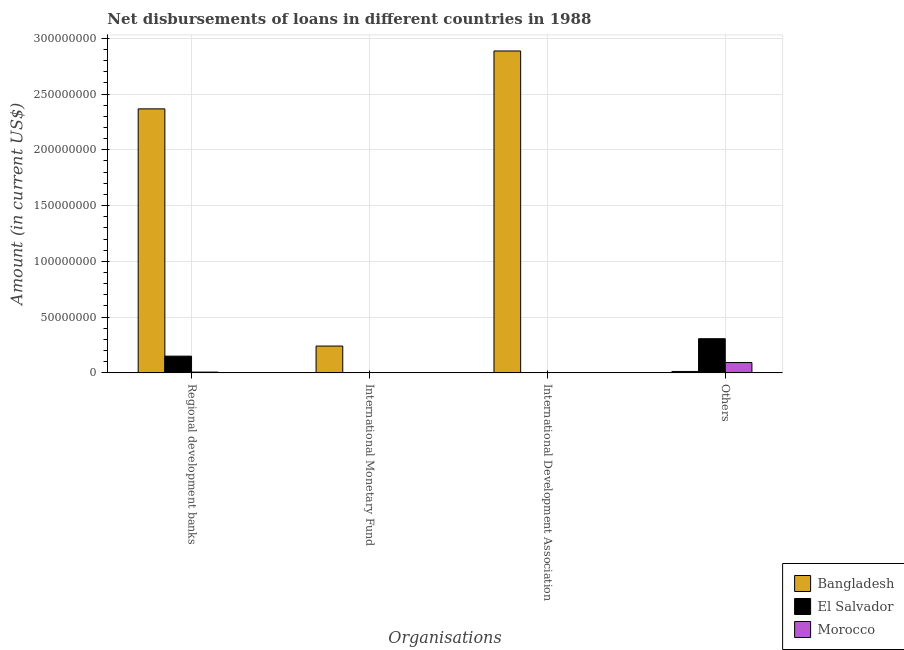What is the label of the 1st group of bars from the left?
Give a very brief answer. Regional development banks. What is the amount of loan disimbursed by other organisations in Morocco?
Your answer should be very brief. 9.26e+06. Across all countries, what is the maximum amount of loan disimbursed by international development association?
Offer a very short reply. 2.89e+08. In which country was the amount of loan disimbursed by regional development banks maximum?
Your response must be concise. Bangladesh. What is the total amount of loan disimbursed by other organisations in the graph?
Your response must be concise. 4.11e+07. What is the difference between the amount of loan disimbursed by other organisations in Morocco and that in El Salvador?
Provide a succinct answer. -2.14e+07. What is the difference between the amount of loan disimbursed by other organisations in Morocco and the amount of loan disimbursed by international monetary fund in Bangladesh?
Keep it short and to the point. -1.48e+07. What is the average amount of loan disimbursed by other organisations per country?
Your answer should be compact. 1.37e+07. What is the difference between the amount of loan disimbursed by other organisations and amount of loan disimbursed by international development association in Bangladesh?
Ensure brevity in your answer.  -2.87e+08. In how many countries, is the amount of loan disimbursed by regional development banks greater than 150000000 US$?
Offer a very short reply. 1. What is the ratio of the amount of loan disimbursed by regional development banks in El Salvador to that in Morocco?
Offer a very short reply. 21.62. Is the amount of loan disimbursed by other organisations in El Salvador less than that in Morocco?
Your response must be concise. No. Is the difference between the amount of loan disimbursed by regional development banks in Morocco and Bangladesh greater than the difference between the amount of loan disimbursed by other organisations in Morocco and Bangladesh?
Give a very brief answer. No. What is the difference between the highest and the second highest amount of loan disimbursed by other organisations?
Provide a short and direct response. 2.14e+07. What is the difference between the highest and the lowest amount of loan disimbursed by international monetary fund?
Provide a short and direct response. 2.40e+07. In how many countries, is the amount of loan disimbursed by regional development banks greater than the average amount of loan disimbursed by regional development banks taken over all countries?
Your response must be concise. 1. How many bars are there?
Offer a very short reply. 8. How many countries are there in the graph?
Give a very brief answer. 3. Are the values on the major ticks of Y-axis written in scientific E-notation?
Your response must be concise. No. Does the graph contain any zero values?
Offer a terse response. Yes. How many legend labels are there?
Ensure brevity in your answer.  3. How are the legend labels stacked?
Your answer should be very brief. Vertical. What is the title of the graph?
Give a very brief answer. Net disbursements of loans in different countries in 1988. What is the label or title of the X-axis?
Offer a terse response. Organisations. What is the label or title of the Y-axis?
Your answer should be compact. Amount (in current US$). What is the Amount (in current US$) in Bangladesh in Regional development banks?
Give a very brief answer. 2.37e+08. What is the Amount (in current US$) of El Salvador in Regional development banks?
Ensure brevity in your answer.  1.50e+07. What is the Amount (in current US$) in Morocco in Regional development banks?
Keep it short and to the point. 6.94e+05. What is the Amount (in current US$) in Bangladesh in International Monetary Fund?
Offer a terse response. 2.40e+07. What is the Amount (in current US$) of El Salvador in International Monetary Fund?
Ensure brevity in your answer.  0. What is the Amount (in current US$) in Bangladesh in International Development Association?
Your answer should be compact. 2.89e+08. What is the Amount (in current US$) of El Salvador in International Development Association?
Offer a very short reply. 0. What is the Amount (in current US$) of Morocco in International Development Association?
Provide a short and direct response. 0. What is the Amount (in current US$) in Bangladesh in Others?
Keep it short and to the point. 1.26e+06. What is the Amount (in current US$) of El Salvador in Others?
Offer a terse response. 3.06e+07. What is the Amount (in current US$) of Morocco in Others?
Your answer should be compact. 9.26e+06. Across all Organisations, what is the maximum Amount (in current US$) of Bangladesh?
Keep it short and to the point. 2.89e+08. Across all Organisations, what is the maximum Amount (in current US$) in El Salvador?
Offer a very short reply. 3.06e+07. Across all Organisations, what is the maximum Amount (in current US$) in Morocco?
Provide a short and direct response. 9.26e+06. Across all Organisations, what is the minimum Amount (in current US$) of Bangladesh?
Make the answer very short. 1.26e+06. Across all Organisations, what is the minimum Amount (in current US$) of El Salvador?
Keep it short and to the point. 0. What is the total Amount (in current US$) in Bangladesh in the graph?
Give a very brief answer. 5.51e+08. What is the total Amount (in current US$) in El Salvador in the graph?
Provide a succinct answer. 4.56e+07. What is the total Amount (in current US$) in Morocco in the graph?
Make the answer very short. 9.95e+06. What is the difference between the Amount (in current US$) of Bangladesh in Regional development banks and that in International Monetary Fund?
Give a very brief answer. 2.13e+08. What is the difference between the Amount (in current US$) of Bangladesh in Regional development banks and that in International Development Association?
Offer a very short reply. -5.19e+07. What is the difference between the Amount (in current US$) in Bangladesh in Regional development banks and that in Others?
Your answer should be compact. 2.35e+08. What is the difference between the Amount (in current US$) of El Salvador in Regional development banks and that in Others?
Give a very brief answer. -1.56e+07. What is the difference between the Amount (in current US$) in Morocco in Regional development banks and that in Others?
Your answer should be very brief. -8.56e+06. What is the difference between the Amount (in current US$) of Bangladesh in International Monetary Fund and that in International Development Association?
Your answer should be compact. -2.65e+08. What is the difference between the Amount (in current US$) of Bangladesh in International Monetary Fund and that in Others?
Ensure brevity in your answer.  2.28e+07. What is the difference between the Amount (in current US$) in Bangladesh in International Development Association and that in Others?
Ensure brevity in your answer.  2.87e+08. What is the difference between the Amount (in current US$) in Bangladesh in Regional development banks and the Amount (in current US$) in El Salvador in Others?
Give a very brief answer. 2.06e+08. What is the difference between the Amount (in current US$) in Bangladesh in Regional development banks and the Amount (in current US$) in Morocco in Others?
Offer a very short reply. 2.27e+08. What is the difference between the Amount (in current US$) in El Salvador in Regional development banks and the Amount (in current US$) in Morocco in Others?
Your response must be concise. 5.75e+06. What is the difference between the Amount (in current US$) in Bangladesh in International Monetary Fund and the Amount (in current US$) in El Salvador in Others?
Keep it short and to the point. -6.58e+06. What is the difference between the Amount (in current US$) in Bangladesh in International Monetary Fund and the Amount (in current US$) in Morocco in Others?
Make the answer very short. 1.48e+07. What is the difference between the Amount (in current US$) of Bangladesh in International Development Association and the Amount (in current US$) of El Salvador in Others?
Your answer should be very brief. 2.58e+08. What is the difference between the Amount (in current US$) in Bangladesh in International Development Association and the Amount (in current US$) in Morocco in Others?
Give a very brief answer. 2.79e+08. What is the average Amount (in current US$) of Bangladesh per Organisations?
Your answer should be compact. 1.38e+08. What is the average Amount (in current US$) in El Salvador per Organisations?
Provide a succinct answer. 1.14e+07. What is the average Amount (in current US$) in Morocco per Organisations?
Your response must be concise. 2.49e+06. What is the difference between the Amount (in current US$) of Bangladesh and Amount (in current US$) of El Salvador in Regional development banks?
Give a very brief answer. 2.22e+08. What is the difference between the Amount (in current US$) in Bangladesh and Amount (in current US$) in Morocco in Regional development banks?
Ensure brevity in your answer.  2.36e+08. What is the difference between the Amount (in current US$) of El Salvador and Amount (in current US$) of Morocco in Regional development banks?
Make the answer very short. 1.43e+07. What is the difference between the Amount (in current US$) of Bangladesh and Amount (in current US$) of El Salvador in Others?
Provide a succinct answer. -2.94e+07. What is the difference between the Amount (in current US$) of Bangladesh and Amount (in current US$) of Morocco in Others?
Provide a succinct answer. -7.99e+06. What is the difference between the Amount (in current US$) in El Salvador and Amount (in current US$) in Morocco in Others?
Your answer should be compact. 2.14e+07. What is the ratio of the Amount (in current US$) of Bangladesh in Regional development banks to that in International Monetary Fund?
Your answer should be very brief. 9.84. What is the ratio of the Amount (in current US$) in Bangladesh in Regional development banks to that in International Development Association?
Your response must be concise. 0.82. What is the ratio of the Amount (in current US$) of Bangladesh in Regional development banks to that in Others?
Keep it short and to the point. 187.13. What is the ratio of the Amount (in current US$) in El Salvador in Regional development banks to that in Others?
Keep it short and to the point. 0.49. What is the ratio of the Amount (in current US$) in Morocco in Regional development banks to that in Others?
Your answer should be compact. 0.07. What is the ratio of the Amount (in current US$) in Bangladesh in International Monetary Fund to that in International Development Association?
Offer a terse response. 0.08. What is the ratio of the Amount (in current US$) of Bangladesh in International Monetary Fund to that in Others?
Your answer should be very brief. 19.01. What is the ratio of the Amount (in current US$) of Bangladesh in International Development Association to that in Others?
Your answer should be compact. 228.17. What is the difference between the highest and the second highest Amount (in current US$) in Bangladesh?
Provide a short and direct response. 5.19e+07. What is the difference between the highest and the lowest Amount (in current US$) in Bangladesh?
Your response must be concise. 2.87e+08. What is the difference between the highest and the lowest Amount (in current US$) in El Salvador?
Ensure brevity in your answer.  3.06e+07. What is the difference between the highest and the lowest Amount (in current US$) of Morocco?
Give a very brief answer. 9.26e+06. 